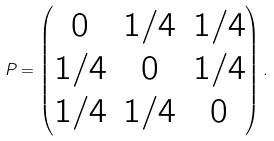<formula> <loc_0><loc_0><loc_500><loc_500>P = \begin{pmatrix} 0 & 1 / 4 & 1 / 4 \\ 1 / 4 & 0 & 1 / 4 \\ 1 / 4 & 1 / 4 & 0 \end{pmatrix} .</formula> 